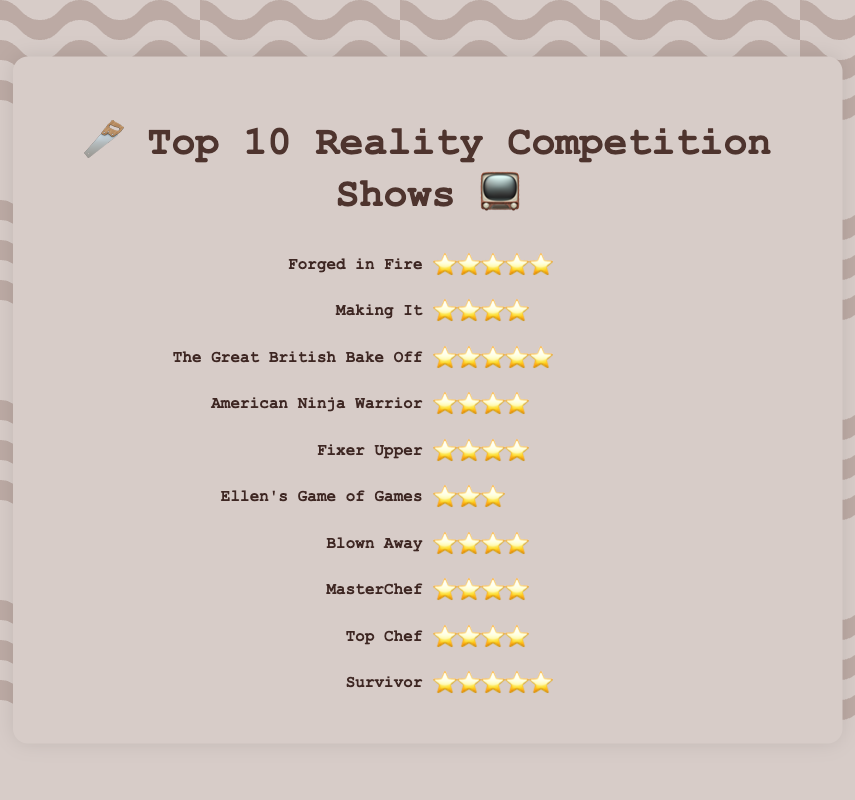Which show has the highest rating? To determine the show with the highest rating, look for the one with the maximum stars. "Forged in Fire," "The Great British Bake Off," and "Survivor" each have 5 stars ⭐⭐⭐⭐⭐.
Answer: Forged in Fire, The Great British Bake Off, Survivor How many shows have a rating of 4 stars? Count the number of shows that have exactly 4 stars. These are "Making It," "American Ninja Warrior," "Fixer Upper," "Blown Away," "MasterChef," and "Top Chef." There are six shows in total.
Answer: 6 Which show has the lowest rating? Identify the show with the fewest stars. "Ellen's Game of Games" has 3 stars ⭐⭐⭐, which is the lowest.
Answer: Ellen's Game of Games Which shows have a rating of 5 stars? List the shows that have 5 stars. They are "Forged in Fire," "The Great British Bake Off," and "Survivor."
Answer: Forged in Fire, The Great British Bake Off, Survivor How many shows have more than 4 stars? Count the shows that have more than 4 stars. All shows with ratings higher than 4 stars are counted. Three shows, "Forged in Fire," "The Great British Bake Off," and "Survivor," have 5 stars, which is higher than 4.
Answer: 3 Which shows have the same rating as "Blown Away"? Determine the rating of "Blown Away" and find other shows with the same number of stars. "Blown Away" has 4 stars ⭐⭐⭐⭐. The other shows with 4 stars are "Making It," "American Ninja Warrior," "Fixer Upper," "MasterChef," and "Top Chef."
Answer: Making It, American Ninja Warrior, Fixer Upper, MasterChef, Top Chef What is the average rating of all shows? Calculate the average stars for all shows. Convert the star ratings to numbers (5, 4, 4, 4, 4, 3, 4, 4, 4, 5). Sum them up (5+4+5+4+4+3+4+4+4+5=42) and divide by the total number of shows (10). 42/10 = 4.2 stars.
Answer: 4.2 What percentage of the shows have a rating of 5 stars? Count the shows with 5 stars and divide by the total number of shows. There are 3 shows with 5 stars out of 10 total shows. So the percentage is (3/10) * 100 = 30%.
Answer: 30% Which has a higher rating, "American Ninja Warrior" or "Ellen's Game of Games"? Compare the stars of "American Ninja Warrior" (4 stars) and "Ellen's Game of Games" (3 stars). "American Ninja Warrior" has a higher rating.
Answer: American Ninja Warrior How many more shows have a rating of 4 stars compared to 3 stars? Count the shows with 4 stars (6 shows) and the shows with 3 stars (1 show). Subtract the number of shows with 3 stars from those with 4 stars. 6 - 1 = 5 shows.
Answer: 5 